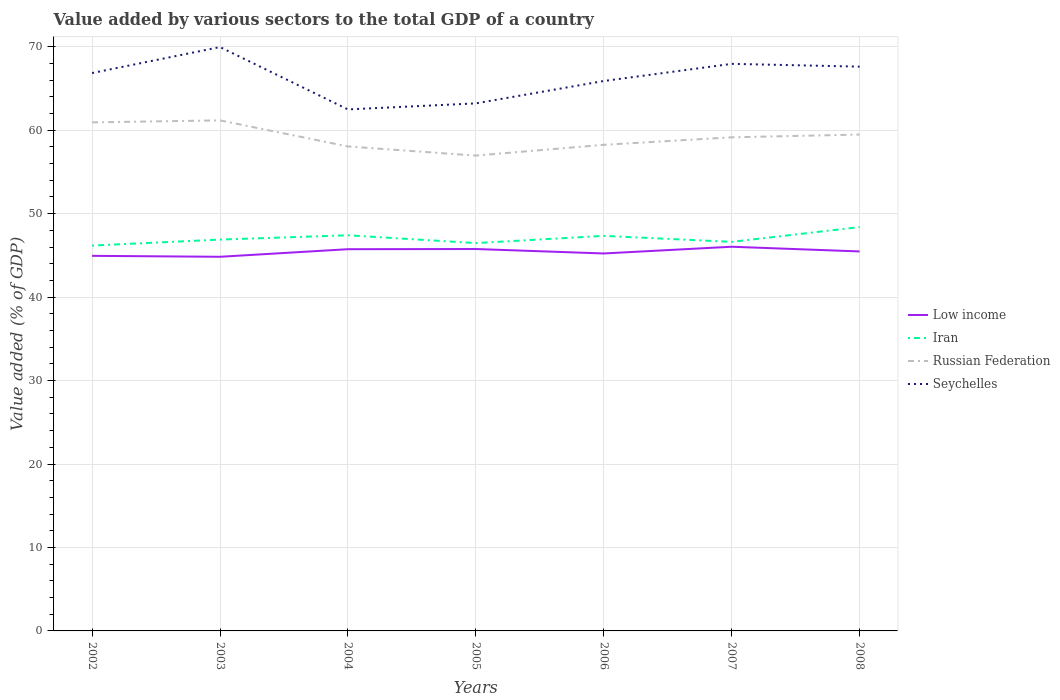How many different coloured lines are there?
Make the answer very short. 4. Is the number of lines equal to the number of legend labels?
Your response must be concise. Yes. Across all years, what is the maximum value added by various sectors to the total GDP in Russian Federation?
Your answer should be compact. 56.96. In which year was the value added by various sectors to the total GDP in Russian Federation maximum?
Offer a terse response. 2005. What is the total value added by various sectors to the total GDP in Iran in the graph?
Offer a terse response. -0.15. What is the difference between the highest and the second highest value added by various sectors to the total GDP in Low income?
Give a very brief answer. 1.2. Does the graph contain any zero values?
Your response must be concise. No. How many legend labels are there?
Keep it short and to the point. 4. What is the title of the graph?
Offer a very short reply. Value added by various sectors to the total GDP of a country. Does "Rwanda" appear as one of the legend labels in the graph?
Make the answer very short. No. What is the label or title of the X-axis?
Ensure brevity in your answer.  Years. What is the label or title of the Y-axis?
Provide a succinct answer. Value added (% of GDP). What is the Value added (% of GDP) in Low income in 2002?
Ensure brevity in your answer.  44.94. What is the Value added (% of GDP) in Iran in 2002?
Give a very brief answer. 46.18. What is the Value added (% of GDP) of Russian Federation in 2002?
Ensure brevity in your answer.  60.94. What is the Value added (% of GDP) in Seychelles in 2002?
Offer a terse response. 66.85. What is the Value added (% of GDP) of Low income in 2003?
Provide a short and direct response. 44.83. What is the Value added (% of GDP) of Iran in 2003?
Your answer should be very brief. 46.89. What is the Value added (% of GDP) in Russian Federation in 2003?
Ensure brevity in your answer.  61.17. What is the Value added (% of GDP) in Seychelles in 2003?
Provide a succinct answer. 69.96. What is the Value added (% of GDP) in Low income in 2004?
Keep it short and to the point. 45.74. What is the Value added (% of GDP) in Iran in 2004?
Offer a terse response. 47.41. What is the Value added (% of GDP) of Russian Federation in 2004?
Ensure brevity in your answer.  58.05. What is the Value added (% of GDP) in Seychelles in 2004?
Provide a succinct answer. 62.49. What is the Value added (% of GDP) of Low income in 2005?
Provide a succinct answer. 45.76. What is the Value added (% of GDP) of Iran in 2005?
Offer a terse response. 46.47. What is the Value added (% of GDP) of Russian Federation in 2005?
Your answer should be very brief. 56.96. What is the Value added (% of GDP) in Seychelles in 2005?
Offer a very short reply. 63.21. What is the Value added (% of GDP) of Low income in 2006?
Your response must be concise. 45.23. What is the Value added (% of GDP) in Iran in 2006?
Provide a succinct answer. 47.34. What is the Value added (% of GDP) of Russian Federation in 2006?
Ensure brevity in your answer.  58.25. What is the Value added (% of GDP) in Seychelles in 2006?
Your answer should be compact. 65.89. What is the Value added (% of GDP) in Low income in 2007?
Ensure brevity in your answer.  46.03. What is the Value added (% of GDP) of Iran in 2007?
Offer a terse response. 46.62. What is the Value added (% of GDP) in Russian Federation in 2007?
Ensure brevity in your answer.  59.15. What is the Value added (% of GDP) of Seychelles in 2007?
Ensure brevity in your answer.  67.95. What is the Value added (% of GDP) in Low income in 2008?
Give a very brief answer. 45.47. What is the Value added (% of GDP) of Iran in 2008?
Your answer should be very brief. 48.39. What is the Value added (% of GDP) of Russian Federation in 2008?
Provide a short and direct response. 59.48. What is the Value added (% of GDP) in Seychelles in 2008?
Make the answer very short. 67.61. Across all years, what is the maximum Value added (% of GDP) of Low income?
Provide a short and direct response. 46.03. Across all years, what is the maximum Value added (% of GDP) in Iran?
Provide a succinct answer. 48.39. Across all years, what is the maximum Value added (% of GDP) of Russian Federation?
Give a very brief answer. 61.17. Across all years, what is the maximum Value added (% of GDP) in Seychelles?
Provide a succinct answer. 69.96. Across all years, what is the minimum Value added (% of GDP) in Low income?
Your answer should be very brief. 44.83. Across all years, what is the minimum Value added (% of GDP) of Iran?
Your answer should be very brief. 46.18. Across all years, what is the minimum Value added (% of GDP) in Russian Federation?
Provide a succinct answer. 56.96. Across all years, what is the minimum Value added (% of GDP) of Seychelles?
Your answer should be compact. 62.49. What is the total Value added (% of GDP) of Low income in the graph?
Offer a terse response. 318. What is the total Value added (% of GDP) in Iran in the graph?
Your answer should be very brief. 329.29. What is the total Value added (% of GDP) of Russian Federation in the graph?
Your answer should be compact. 413.99. What is the total Value added (% of GDP) in Seychelles in the graph?
Provide a short and direct response. 463.97. What is the difference between the Value added (% of GDP) of Low income in 2002 and that in 2003?
Make the answer very short. 0.11. What is the difference between the Value added (% of GDP) in Iran in 2002 and that in 2003?
Provide a succinct answer. -0.72. What is the difference between the Value added (% of GDP) of Russian Federation in 2002 and that in 2003?
Provide a succinct answer. -0.24. What is the difference between the Value added (% of GDP) in Seychelles in 2002 and that in 2003?
Your response must be concise. -3.11. What is the difference between the Value added (% of GDP) in Low income in 2002 and that in 2004?
Keep it short and to the point. -0.8. What is the difference between the Value added (% of GDP) in Iran in 2002 and that in 2004?
Give a very brief answer. -1.23. What is the difference between the Value added (% of GDP) in Russian Federation in 2002 and that in 2004?
Make the answer very short. 2.88. What is the difference between the Value added (% of GDP) in Seychelles in 2002 and that in 2004?
Your response must be concise. 4.36. What is the difference between the Value added (% of GDP) in Low income in 2002 and that in 2005?
Provide a short and direct response. -0.82. What is the difference between the Value added (% of GDP) in Iran in 2002 and that in 2005?
Your answer should be compact. -0.3. What is the difference between the Value added (% of GDP) of Russian Federation in 2002 and that in 2005?
Make the answer very short. 3.98. What is the difference between the Value added (% of GDP) of Seychelles in 2002 and that in 2005?
Your answer should be very brief. 3.64. What is the difference between the Value added (% of GDP) in Low income in 2002 and that in 2006?
Your response must be concise. -0.29. What is the difference between the Value added (% of GDP) of Iran in 2002 and that in 2006?
Provide a succinct answer. -1.16. What is the difference between the Value added (% of GDP) of Russian Federation in 2002 and that in 2006?
Make the answer very short. 2.69. What is the difference between the Value added (% of GDP) in Seychelles in 2002 and that in 2006?
Ensure brevity in your answer.  0.95. What is the difference between the Value added (% of GDP) of Low income in 2002 and that in 2007?
Your answer should be very brief. -1.09. What is the difference between the Value added (% of GDP) in Iran in 2002 and that in 2007?
Give a very brief answer. -0.44. What is the difference between the Value added (% of GDP) in Russian Federation in 2002 and that in 2007?
Offer a terse response. 1.79. What is the difference between the Value added (% of GDP) of Seychelles in 2002 and that in 2007?
Keep it short and to the point. -1.1. What is the difference between the Value added (% of GDP) in Low income in 2002 and that in 2008?
Ensure brevity in your answer.  -0.53. What is the difference between the Value added (% of GDP) of Iran in 2002 and that in 2008?
Ensure brevity in your answer.  -2.22. What is the difference between the Value added (% of GDP) of Russian Federation in 2002 and that in 2008?
Your response must be concise. 1.46. What is the difference between the Value added (% of GDP) in Seychelles in 2002 and that in 2008?
Provide a succinct answer. -0.77. What is the difference between the Value added (% of GDP) of Low income in 2003 and that in 2004?
Make the answer very short. -0.91. What is the difference between the Value added (% of GDP) of Iran in 2003 and that in 2004?
Your answer should be very brief. -0.52. What is the difference between the Value added (% of GDP) in Russian Federation in 2003 and that in 2004?
Keep it short and to the point. 3.12. What is the difference between the Value added (% of GDP) in Seychelles in 2003 and that in 2004?
Your response must be concise. 7.47. What is the difference between the Value added (% of GDP) of Low income in 2003 and that in 2005?
Your response must be concise. -0.93. What is the difference between the Value added (% of GDP) in Iran in 2003 and that in 2005?
Offer a terse response. 0.42. What is the difference between the Value added (% of GDP) in Russian Federation in 2003 and that in 2005?
Your response must be concise. 4.22. What is the difference between the Value added (% of GDP) in Seychelles in 2003 and that in 2005?
Make the answer very short. 6.75. What is the difference between the Value added (% of GDP) of Low income in 2003 and that in 2006?
Ensure brevity in your answer.  -0.4. What is the difference between the Value added (% of GDP) of Iran in 2003 and that in 2006?
Offer a very short reply. -0.45. What is the difference between the Value added (% of GDP) in Russian Federation in 2003 and that in 2006?
Provide a short and direct response. 2.93. What is the difference between the Value added (% of GDP) in Seychelles in 2003 and that in 2006?
Offer a terse response. 4.07. What is the difference between the Value added (% of GDP) in Low income in 2003 and that in 2007?
Give a very brief answer. -1.2. What is the difference between the Value added (% of GDP) in Iran in 2003 and that in 2007?
Give a very brief answer. 0.27. What is the difference between the Value added (% of GDP) of Russian Federation in 2003 and that in 2007?
Provide a succinct answer. 2.03. What is the difference between the Value added (% of GDP) in Seychelles in 2003 and that in 2007?
Your response must be concise. 2.01. What is the difference between the Value added (% of GDP) of Low income in 2003 and that in 2008?
Provide a short and direct response. -0.64. What is the difference between the Value added (% of GDP) in Iran in 2003 and that in 2008?
Keep it short and to the point. -1.5. What is the difference between the Value added (% of GDP) of Russian Federation in 2003 and that in 2008?
Your response must be concise. 1.7. What is the difference between the Value added (% of GDP) in Seychelles in 2003 and that in 2008?
Ensure brevity in your answer.  2.35. What is the difference between the Value added (% of GDP) in Low income in 2004 and that in 2005?
Give a very brief answer. -0.02. What is the difference between the Value added (% of GDP) of Iran in 2004 and that in 2005?
Make the answer very short. 0.94. What is the difference between the Value added (% of GDP) in Russian Federation in 2004 and that in 2005?
Make the answer very short. 1.1. What is the difference between the Value added (% of GDP) in Seychelles in 2004 and that in 2005?
Your answer should be compact. -0.73. What is the difference between the Value added (% of GDP) of Low income in 2004 and that in 2006?
Offer a terse response. 0.51. What is the difference between the Value added (% of GDP) in Iran in 2004 and that in 2006?
Ensure brevity in your answer.  0.07. What is the difference between the Value added (% of GDP) in Russian Federation in 2004 and that in 2006?
Provide a short and direct response. -0.2. What is the difference between the Value added (% of GDP) of Seychelles in 2004 and that in 2006?
Your response must be concise. -3.41. What is the difference between the Value added (% of GDP) of Low income in 2004 and that in 2007?
Ensure brevity in your answer.  -0.3. What is the difference between the Value added (% of GDP) in Iran in 2004 and that in 2007?
Provide a short and direct response. 0.79. What is the difference between the Value added (% of GDP) of Russian Federation in 2004 and that in 2007?
Offer a terse response. -1.1. What is the difference between the Value added (% of GDP) of Seychelles in 2004 and that in 2007?
Your answer should be very brief. -5.46. What is the difference between the Value added (% of GDP) of Low income in 2004 and that in 2008?
Provide a succinct answer. 0.27. What is the difference between the Value added (% of GDP) of Iran in 2004 and that in 2008?
Your answer should be very brief. -0.98. What is the difference between the Value added (% of GDP) in Russian Federation in 2004 and that in 2008?
Keep it short and to the point. -1.43. What is the difference between the Value added (% of GDP) in Seychelles in 2004 and that in 2008?
Provide a succinct answer. -5.13. What is the difference between the Value added (% of GDP) of Low income in 2005 and that in 2006?
Offer a terse response. 0.53. What is the difference between the Value added (% of GDP) in Iran in 2005 and that in 2006?
Offer a very short reply. -0.87. What is the difference between the Value added (% of GDP) of Russian Federation in 2005 and that in 2006?
Give a very brief answer. -1.29. What is the difference between the Value added (% of GDP) of Seychelles in 2005 and that in 2006?
Your response must be concise. -2.68. What is the difference between the Value added (% of GDP) of Low income in 2005 and that in 2007?
Ensure brevity in your answer.  -0.27. What is the difference between the Value added (% of GDP) of Iran in 2005 and that in 2007?
Your answer should be very brief. -0.15. What is the difference between the Value added (% of GDP) of Russian Federation in 2005 and that in 2007?
Your answer should be very brief. -2.19. What is the difference between the Value added (% of GDP) of Seychelles in 2005 and that in 2007?
Provide a short and direct response. -4.74. What is the difference between the Value added (% of GDP) of Low income in 2005 and that in 2008?
Keep it short and to the point. 0.29. What is the difference between the Value added (% of GDP) in Iran in 2005 and that in 2008?
Make the answer very short. -1.92. What is the difference between the Value added (% of GDP) of Russian Federation in 2005 and that in 2008?
Offer a very short reply. -2.52. What is the difference between the Value added (% of GDP) of Seychelles in 2005 and that in 2008?
Make the answer very short. -4.4. What is the difference between the Value added (% of GDP) of Low income in 2006 and that in 2007?
Provide a short and direct response. -0.81. What is the difference between the Value added (% of GDP) of Iran in 2006 and that in 2007?
Offer a terse response. 0.72. What is the difference between the Value added (% of GDP) in Russian Federation in 2006 and that in 2007?
Ensure brevity in your answer.  -0.9. What is the difference between the Value added (% of GDP) in Seychelles in 2006 and that in 2007?
Your response must be concise. -2.05. What is the difference between the Value added (% of GDP) of Low income in 2006 and that in 2008?
Give a very brief answer. -0.24. What is the difference between the Value added (% of GDP) in Iran in 2006 and that in 2008?
Offer a very short reply. -1.05. What is the difference between the Value added (% of GDP) in Russian Federation in 2006 and that in 2008?
Offer a terse response. -1.23. What is the difference between the Value added (% of GDP) of Seychelles in 2006 and that in 2008?
Your response must be concise. -1.72. What is the difference between the Value added (% of GDP) in Low income in 2007 and that in 2008?
Offer a terse response. 0.56. What is the difference between the Value added (% of GDP) of Iran in 2007 and that in 2008?
Keep it short and to the point. -1.77. What is the difference between the Value added (% of GDP) of Russian Federation in 2007 and that in 2008?
Provide a short and direct response. -0.33. What is the difference between the Value added (% of GDP) in Seychelles in 2007 and that in 2008?
Your answer should be compact. 0.33. What is the difference between the Value added (% of GDP) of Low income in 2002 and the Value added (% of GDP) of Iran in 2003?
Make the answer very short. -1.95. What is the difference between the Value added (% of GDP) in Low income in 2002 and the Value added (% of GDP) in Russian Federation in 2003?
Offer a very short reply. -16.23. What is the difference between the Value added (% of GDP) of Low income in 2002 and the Value added (% of GDP) of Seychelles in 2003?
Your answer should be very brief. -25.02. What is the difference between the Value added (% of GDP) in Iran in 2002 and the Value added (% of GDP) in Russian Federation in 2003?
Your response must be concise. -15. What is the difference between the Value added (% of GDP) of Iran in 2002 and the Value added (% of GDP) of Seychelles in 2003?
Keep it short and to the point. -23.79. What is the difference between the Value added (% of GDP) of Russian Federation in 2002 and the Value added (% of GDP) of Seychelles in 2003?
Give a very brief answer. -9.02. What is the difference between the Value added (% of GDP) of Low income in 2002 and the Value added (% of GDP) of Iran in 2004?
Make the answer very short. -2.47. What is the difference between the Value added (% of GDP) of Low income in 2002 and the Value added (% of GDP) of Russian Federation in 2004?
Your answer should be compact. -13.11. What is the difference between the Value added (% of GDP) of Low income in 2002 and the Value added (% of GDP) of Seychelles in 2004?
Provide a succinct answer. -17.54. What is the difference between the Value added (% of GDP) in Iran in 2002 and the Value added (% of GDP) in Russian Federation in 2004?
Ensure brevity in your answer.  -11.88. What is the difference between the Value added (% of GDP) of Iran in 2002 and the Value added (% of GDP) of Seychelles in 2004?
Your answer should be very brief. -16.31. What is the difference between the Value added (% of GDP) in Russian Federation in 2002 and the Value added (% of GDP) in Seychelles in 2004?
Ensure brevity in your answer.  -1.55. What is the difference between the Value added (% of GDP) in Low income in 2002 and the Value added (% of GDP) in Iran in 2005?
Keep it short and to the point. -1.53. What is the difference between the Value added (% of GDP) in Low income in 2002 and the Value added (% of GDP) in Russian Federation in 2005?
Your answer should be very brief. -12.01. What is the difference between the Value added (% of GDP) of Low income in 2002 and the Value added (% of GDP) of Seychelles in 2005?
Offer a terse response. -18.27. What is the difference between the Value added (% of GDP) in Iran in 2002 and the Value added (% of GDP) in Russian Federation in 2005?
Ensure brevity in your answer.  -10.78. What is the difference between the Value added (% of GDP) of Iran in 2002 and the Value added (% of GDP) of Seychelles in 2005?
Offer a very short reply. -17.04. What is the difference between the Value added (% of GDP) in Russian Federation in 2002 and the Value added (% of GDP) in Seychelles in 2005?
Your response must be concise. -2.28. What is the difference between the Value added (% of GDP) of Low income in 2002 and the Value added (% of GDP) of Iran in 2006?
Make the answer very short. -2.39. What is the difference between the Value added (% of GDP) in Low income in 2002 and the Value added (% of GDP) in Russian Federation in 2006?
Your answer should be very brief. -13.3. What is the difference between the Value added (% of GDP) of Low income in 2002 and the Value added (% of GDP) of Seychelles in 2006?
Ensure brevity in your answer.  -20.95. What is the difference between the Value added (% of GDP) of Iran in 2002 and the Value added (% of GDP) of Russian Federation in 2006?
Keep it short and to the point. -12.07. What is the difference between the Value added (% of GDP) in Iran in 2002 and the Value added (% of GDP) in Seychelles in 2006?
Your response must be concise. -19.72. What is the difference between the Value added (% of GDP) of Russian Federation in 2002 and the Value added (% of GDP) of Seychelles in 2006?
Your response must be concise. -4.96. What is the difference between the Value added (% of GDP) in Low income in 2002 and the Value added (% of GDP) in Iran in 2007?
Your response must be concise. -1.68. What is the difference between the Value added (% of GDP) in Low income in 2002 and the Value added (% of GDP) in Russian Federation in 2007?
Ensure brevity in your answer.  -14.2. What is the difference between the Value added (% of GDP) of Low income in 2002 and the Value added (% of GDP) of Seychelles in 2007?
Ensure brevity in your answer.  -23.01. What is the difference between the Value added (% of GDP) of Iran in 2002 and the Value added (% of GDP) of Russian Federation in 2007?
Provide a succinct answer. -12.97. What is the difference between the Value added (% of GDP) of Iran in 2002 and the Value added (% of GDP) of Seychelles in 2007?
Your answer should be compact. -21.77. What is the difference between the Value added (% of GDP) of Russian Federation in 2002 and the Value added (% of GDP) of Seychelles in 2007?
Make the answer very short. -7.01. What is the difference between the Value added (% of GDP) in Low income in 2002 and the Value added (% of GDP) in Iran in 2008?
Give a very brief answer. -3.45. What is the difference between the Value added (% of GDP) of Low income in 2002 and the Value added (% of GDP) of Russian Federation in 2008?
Your answer should be compact. -14.53. What is the difference between the Value added (% of GDP) of Low income in 2002 and the Value added (% of GDP) of Seychelles in 2008?
Give a very brief answer. -22.67. What is the difference between the Value added (% of GDP) of Iran in 2002 and the Value added (% of GDP) of Russian Federation in 2008?
Offer a terse response. -13.3. What is the difference between the Value added (% of GDP) of Iran in 2002 and the Value added (% of GDP) of Seychelles in 2008?
Offer a very short reply. -21.44. What is the difference between the Value added (% of GDP) in Russian Federation in 2002 and the Value added (% of GDP) in Seychelles in 2008?
Your answer should be compact. -6.68. What is the difference between the Value added (% of GDP) in Low income in 2003 and the Value added (% of GDP) in Iran in 2004?
Give a very brief answer. -2.58. What is the difference between the Value added (% of GDP) of Low income in 2003 and the Value added (% of GDP) of Russian Federation in 2004?
Make the answer very short. -13.22. What is the difference between the Value added (% of GDP) of Low income in 2003 and the Value added (% of GDP) of Seychelles in 2004?
Offer a terse response. -17.66. What is the difference between the Value added (% of GDP) of Iran in 2003 and the Value added (% of GDP) of Russian Federation in 2004?
Ensure brevity in your answer.  -11.16. What is the difference between the Value added (% of GDP) in Iran in 2003 and the Value added (% of GDP) in Seychelles in 2004?
Provide a short and direct response. -15.6. What is the difference between the Value added (% of GDP) in Russian Federation in 2003 and the Value added (% of GDP) in Seychelles in 2004?
Provide a short and direct response. -1.31. What is the difference between the Value added (% of GDP) of Low income in 2003 and the Value added (% of GDP) of Iran in 2005?
Provide a succinct answer. -1.64. What is the difference between the Value added (% of GDP) of Low income in 2003 and the Value added (% of GDP) of Russian Federation in 2005?
Your answer should be very brief. -12.13. What is the difference between the Value added (% of GDP) of Low income in 2003 and the Value added (% of GDP) of Seychelles in 2005?
Ensure brevity in your answer.  -18.38. What is the difference between the Value added (% of GDP) in Iran in 2003 and the Value added (% of GDP) in Russian Federation in 2005?
Your answer should be very brief. -10.06. What is the difference between the Value added (% of GDP) of Iran in 2003 and the Value added (% of GDP) of Seychelles in 2005?
Give a very brief answer. -16.32. What is the difference between the Value added (% of GDP) of Russian Federation in 2003 and the Value added (% of GDP) of Seychelles in 2005?
Offer a terse response. -2.04. What is the difference between the Value added (% of GDP) of Low income in 2003 and the Value added (% of GDP) of Iran in 2006?
Offer a terse response. -2.51. What is the difference between the Value added (% of GDP) in Low income in 2003 and the Value added (% of GDP) in Russian Federation in 2006?
Offer a very short reply. -13.42. What is the difference between the Value added (% of GDP) in Low income in 2003 and the Value added (% of GDP) in Seychelles in 2006?
Offer a very short reply. -21.06. What is the difference between the Value added (% of GDP) in Iran in 2003 and the Value added (% of GDP) in Russian Federation in 2006?
Provide a short and direct response. -11.36. What is the difference between the Value added (% of GDP) in Iran in 2003 and the Value added (% of GDP) in Seychelles in 2006?
Your answer should be very brief. -19. What is the difference between the Value added (% of GDP) in Russian Federation in 2003 and the Value added (% of GDP) in Seychelles in 2006?
Provide a succinct answer. -4.72. What is the difference between the Value added (% of GDP) in Low income in 2003 and the Value added (% of GDP) in Iran in 2007?
Keep it short and to the point. -1.79. What is the difference between the Value added (% of GDP) of Low income in 2003 and the Value added (% of GDP) of Russian Federation in 2007?
Keep it short and to the point. -14.32. What is the difference between the Value added (% of GDP) of Low income in 2003 and the Value added (% of GDP) of Seychelles in 2007?
Offer a very short reply. -23.12. What is the difference between the Value added (% of GDP) of Iran in 2003 and the Value added (% of GDP) of Russian Federation in 2007?
Make the answer very short. -12.26. What is the difference between the Value added (% of GDP) of Iran in 2003 and the Value added (% of GDP) of Seychelles in 2007?
Keep it short and to the point. -21.06. What is the difference between the Value added (% of GDP) of Russian Federation in 2003 and the Value added (% of GDP) of Seychelles in 2007?
Your answer should be compact. -6.77. What is the difference between the Value added (% of GDP) of Low income in 2003 and the Value added (% of GDP) of Iran in 2008?
Keep it short and to the point. -3.56. What is the difference between the Value added (% of GDP) in Low income in 2003 and the Value added (% of GDP) in Russian Federation in 2008?
Ensure brevity in your answer.  -14.65. What is the difference between the Value added (% of GDP) in Low income in 2003 and the Value added (% of GDP) in Seychelles in 2008?
Your answer should be compact. -22.78. What is the difference between the Value added (% of GDP) of Iran in 2003 and the Value added (% of GDP) of Russian Federation in 2008?
Offer a terse response. -12.59. What is the difference between the Value added (% of GDP) in Iran in 2003 and the Value added (% of GDP) in Seychelles in 2008?
Make the answer very short. -20.72. What is the difference between the Value added (% of GDP) of Russian Federation in 2003 and the Value added (% of GDP) of Seychelles in 2008?
Offer a very short reply. -6.44. What is the difference between the Value added (% of GDP) of Low income in 2004 and the Value added (% of GDP) of Iran in 2005?
Provide a short and direct response. -0.73. What is the difference between the Value added (% of GDP) in Low income in 2004 and the Value added (% of GDP) in Russian Federation in 2005?
Ensure brevity in your answer.  -11.22. What is the difference between the Value added (% of GDP) in Low income in 2004 and the Value added (% of GDP) in Seychelles in 2005?
Your response must be concise. -17.47. What is the difference between the Value added (% of GDP) of Iran in 2004 and the Value added (% of GDP) of Russian Federation in 2005?
Offer a very short reply. -9.55. What is the difference between the Value added (% of GDP) of Iran in 2004 and the Value added (% of GDP) of Seychelles in 2005?
Your response must be concise. -15.8. What is the difference between the Value added (% of GDP) in Russian Federation in 2004 and the Value added (% of GDP) in Seychelles in 2005?
Offer a very short reply. -5.16. What is the difference between the Value added (% of GDP) in Low income in 2004 and the Value added (% of GDP) in Iran in 2006?
Provide a succinct answer. -1.6. What is the difference between the Value added (% of GDP) of Low income in 2004 and the Value added (% of GDP) of Russian Federation in 2006?
Offer a terse response. -12.51. What is the difference between the Value added (% of GDP) in Low income in 2004 and the Value added (% of GDP) in Seychelles in 2006?
Provide a short and direct response. -20.16. What is the difference between the Value added (% of GDP) of Iran in 2004 and the Value added (% of GDP) of Russian Federation in 2006?
Ensure brevity in your answer.  -10.84. What is the difference between the Value added (% of GDP) in Iran in 2004 and the Value added (% of GDP) in Seychelles in 2006?
Ensure brevity in your answer.  -18.49. What is the difference between the Value added (% of GDP) of Russian Federation in 2004 and the Value added (% of GDP) of Seychelles in 2006?
Ensure brevity in your answer.  -7.84. What is the difference between the Value added (% of GDP) of Low income in 2004 and the Value added (% of GDP) of Iran in 2007?
Offer a terse response. -0.88. What is the difference between the Value added (% of GDP) in Low income in 2004 and the Value added (% of GDP) in Russian Federation in 2007?
Ensure brevity in your answer.  -13.41. What is the difference between the Value added (% of GDP) of Low income in 2004 and the Value added (% of GDP) of Seychelles in 2007?
Your answer should be compact. -22.21. What is the difference between the Value added (% of GDP) of Iran in 2004 and the Value added (% of GDP) of Russian Federation in 2007?
Your answer should be compact. -11.74. What is the difference between the Value added (% of GDP) in Iran in 2004 and the Value added (% of GDP) in Seychelles in 2007?
Provide a short and direct response. -20.54. What is the difference between the Value added (% of GDP) in Russian Federation in 2004 and the Value added (% of GDP) in Seychelles in 2007?
Your answer should be very brief. -9.9. What is the difference between the Value added (% of GDP) in Low income in 2004 and the Value added (% of GDP) in Iran in 2008?
Offer a terse response. -2.65. What is the difference between the Value added (% of GDP) of Low income in 2004 and the Value added (% of GDP) of Russian Federation in 2008?
Your answer should be compact. -13.74. What is the difference between the Value added (% of GDP) in Low income in 2004 and the Value added (% of GDP) in Seychelles in 2008?
Keep it short and to the point. -21.88. What is the difference between the Value added (% of GDP) of Iran in 2004 and the Value added (% of GDP) of Russian Federation in 2008?
Your answer should be very brief. -12.07. What is the difference between the Value added (% of GDP) of Iran in 2004 and the Value added (% of GDP) of Seychelles in 2008?
Your response must be concise. -20.21. What is the difference between the Value added (% of GDP) in Russian Federation in 2004 and the Value added (% of GDP) in Seychelles in 2008?
Give a very brief answer. -9.56. What is the difference between the Value added (% of GDP) in Low income in 2005 and the Value added (% of GDP) in Iran in 2006?
Your answer should be compact. -1.58. What is the difference between the Value added (% of GDP) of Low income in 2005 and the Value added (% of GDP) of Russian Federation in 2006?
Ensure brevity in your answer.  -12.49. What is the difference between the Value added (% of GDP) in Low income in 2005 and the Value added (% of GDP) in Seychelles in 2006?
Offer a terse response. -20.13. What is the difference between the Value added (% of GDP) in Iran in 2005 and the Value added (% of GDP) in Russian Federation in 2006?
Make the answer very short. -11.78. What is the difference between the Value added (% of GDP) of Iran in 2005 and the Value added (% of GDP) of Seychelles in 2006?
Offer a very short reply. -19.42. What is the difference between the Value added (% of GDP) in Russian Federation in 2005 and the Value added (% of GDP) in Seychelles in 2006?
Offer a terse response. -8.94. What is the difference between the Value added (% of GDP) in Low income in 2005 and the Value added (% of GDP) in Iran in 2007?
Your answer should be compact. -0.86. What is the difference between the Value added (% of GDP) of Low income in 2005 and the Value added (% of GDP) of Russian Federation in 2007?
Give a very brief answer. -13.39. What is the difference between the Value added (% of GDP) in Low income in 2005 and the Value added (% of GDP) in Seychelles in 2007?
Offer a terse response. -22.19. What is the difference between the Value added (% of GDP) of Iran in 2005 and the Value added (% of GDP) of Russian Federation in 2007?
Your response must be concise. -12.68. What is the difference between the Value added (% of GDP) in Iran in 2005 and the Value added (% of GDP) in Seychelles in 2007?
Your answer should be very brief. -21.48. What is the difference between the Value added (% of GDP) in Russian Federation in 2005 and the Value added (% of GDP) in Seychelles in 2007?
Your answer should be very brief. -10.99. What is the difference between the Value added (% of GDP) in Low income in 2005 and the Value added (% of GDP) in Iran in 2008?
Offer a very short reply. -2.63. What is the difference between the Value added (% of GDP) in Low income in 2005 and the Value added (% of GDP) in Russian Federation in 2008?
Keep it short and to the point. -13.72. What is the difference between the Value added (% of GDP) of Low income in 2005 and the Value added (% of GDP) of Seychelles in 2008?
Make the answer very short. -21.85. What is the difference between the Value added (% of GDP) in Iran in 2005 and the Value added (% of GDP) in Russian Federation in 2008?
Provide a succinct answer. -13.01. What is the difference between the Value added (% of GDP) of Iran in 2005 and the Value added (% of GDP) of Seychelles in 2008?
Ensure brevity in your answer.  -21.14. What is the difference between the Value added (% of GDP) in Russian Federation in 2005 and the Value added (% of GDP) in Seychelles in 2008?
Make the answer very short. -10.66. What is the difference between the Value added (% of GDP) in Low income in 2006 and the Value added (% of GDP) in Iran in 2007?
Provide a succinct answer. -1.39. What is the difference between the Value added (% of GDP) in Low income in 2006 and the Value added (% of GDP) in Russian Federation in 2007?
Provide a short and direct response. -13.92. What is the difference between the Value added (% of GDP) in Low income in 2006 and the Value added (% of GDP) in Seychelles in 2007?
Make the answer very short. -22.72. What is the difference between the Value added (% of GDP) of Iran in 2006 and the Value added (% of GDP) of Russian Federation in 2007?
Provide a short and direct response. -11.81. What is the difference between the Value added (% of GDP) in Iran in 2006 and the Value added (% of GDP) in Seychelles in 2007?
Ensure brevity in your answer.  -20.61. What is the difference between the Value added (% of GDP) of Russian Federation in 2006 and the Value added (% of GDP) of Seychelles in 2007?
Provide a succinct answer. -9.7. What is the difference between the Value added (% of GDP) of Low income in 2006 and the Value added (% of GDP) of Iran in 2008?
Ensure brevity in your answer.  -3.16. What is the difference between the Value added (% of GDP) of Low income in 2006 and the Value added (% of GDP) of Russian Federation in 2008?
Keep it short and to the point. -14.25. What is the difference between the Value added (% of GDP) of Low income in 2006 and the Value added (% of GDP) of Seychelles in 2008?
Provide a succinct answer. -22.39. What is the difference between the Value added (% of GDP) in Iran in 2006 and the Value added (% of GDP) in Russian Federation in 2008?
Offer a terse response. -12.14. What is the difference between the Value added (% of GDP) in Iran in 2006 and the Value added (% of GDP) in Seychelles in 2008?
Provide a short and direct response. -20.28. What is the difference between the Value added (% of GDP) in Russian Federation in 2006 and the Value added (% of GDP) in Seychelles in 2008?
Your answer should be compact. -9.37. What is the difference between the Value added (% of GDP) of Low income in 2007 and the Value added (% of GDP) of Iran in 2008?
Provide a succinct answer. -2.36. What is the difference between the Value added (% of GDP) in Low income in 2007 and the Value added (% of GDP) in Russian Federation in 2008?
Your answer should be compact. -13.44. What is the difference between the Value added (% of GDP) of Low income in 2007 and the Value added (% of GDP) of Seychelles in 2008?
Your answer should be compact. -21.58. What is the difference between the Value added (% of GDP) in Iran in 2007 and the Value added (% of GDP) in Russian Federation in 2008?
Your answer should be compact. -12.86. What is the difference between the Value added (% of GDP) of Iran in 2007 and the Value added (% of GDP) of Seychelles in 2008?
Your response must be concise. -21. What is the difference between the Value added (% of GDP) of Russian Federation in 2007 and the Value added (% of GDP) of Seychelles in 2008?
Provide a succinct answer. -8.47. What is the average Value added (% of GDP) in Low income per year?
Offer a terse response. 45.43. What is the average Value added (% of GDP) of Iran per year?
Offer a very short reply. 47.04. What is the average Value added (% of GDP) of Russian Federation per year?
Your answer should be compact. 59.14. What is the average Value added (% of GDP) of Seychelles per year?
Your answer should be very brief. 66.28. In the year 2002, what is the difference between the Value added (% of GDP) of Low income and Value added (% of GDP) of Iran?
Your answer should be very brief. -1.23. In the year 2002, what is the difference between the Value added (% of GDP) of Low income and Value added (% of GDP) of Russian Federation?
Your answer should be compact. -15.99. In the year 2002, what is the difference between the Value added (% of GDP) in Low income and Value added (% of GDP) in Seychelles?
Your answer should be very brief. -21.91. In the year 2002, what is the difference between the Value added (% of GDP) in Iran and Value added (% of GDP) in Russian Federation?
Ensure brevity in your answer.  -14.76. In the year 2002, what is the difference between the Value added (% of GDP) in Iran and Value added (% of GDP) in Seychelles?
Provide a short and direct response. -20.67. In the year 2002, what is the difference between the Value added (% of GDP) of Russian Federation and Value added (% of GDP) of Seychelles?
Make the answer very short. -5.91. In the year 2003, what is the difference between the Value added (% of GDP) of Low income and Value added (% of GDP) of Iran?
Give a very brief answer. -2.06. In the year 2003, what is the difference between the Value added (% of GDP) in Low income and Value added (% of GDP) in Russian Federation?
Your answer should be compact. -16.34. In the year 2003, what is the difference between the Value added (% of GDP) in Low income and Value added (% of GDP) in Seychelles?
Your answer should be compact. -25.13. In the year 2003, what is the difference between the Value added (% of GDP) in Iran and Value added (% of GDP) in Russian Federation?
Provide a short and direct response. -14.28. In the year 2003, what is the difference between the Value added (% of GDP) in Iran and Value added (% of GDP) in Seychelles?
Your answer should be very brief. -23.07. In the year 2003, what is the difference between the Value added (% of GDP) in Russian Federation and Value added (% of GDP) in Seychelles?
Ensure brevity in your answer.  -8.79. In the year 2004, what is the difference between the Value added (% of GDP) in Low income and Value added (% of GDP) in Iran?
Your answer should be very brief. -1.67. In the year 2004, what is the difference between the Value added (% of GDP) in Low income and Value added (% of GDP) in Russian Federation?
Make the answer very short. -12.31. In the year 2004, what is the difference between the Value added (% of GDP) in Low income and Value added (% of GDP) in Seychelles?
Give a very brief answer. -16.75. In the year 2004, what is the difference between the Value added (% of GDP) in Iran and Value added (% of GDP) in Russian Federation?
Your answer should be very brief. -10.64. In the year 2004, what is the difference between the Value added (% of GDP) in Iran and Value added (% of GDP) in Seychelles?
Offer a terse response. -15.08. In the year 2004, what is the difference between the Value added (% of GDP) in Russian Federation and Value added (% of GDP) in Seychelles?
Give a very brief answer. -4.44. In the year 2005, what is the difference between the Value added (% of GDP) of Low income and Value added (% of GDP) of Iran?
Keep it short and to the point. -0.71. In the year 2005, what is the difference between the Value added (% of GDP) of Low income and Value added (% of GDP) of Russian Federation?
Your answer should be very brief. -11.2. In the year 2005, what is the difference between the Value added (% of GDP) of Low income and Value added (% of GDP) of Seychelles?
Keep it short and to the point. -17.45. In the year 2005, what is the difference between the Value added (% of GDP) of Iran and Value added (% of GDP) of Russian Federation?
Your answer should be very brief. -10.48. In the year 2005, what is the difference between the Value added (% of GDP) of Iran and Value added (% of GDP) of Seychelles?
Your answer should be compact. -16.74. In the year 2005, what is the difference between the Value added (% of GDP) of Russian Federation and Value added (% of GDP) of Seychelles?
Keep it short and to the point. -6.26. In the year 2006, what is the difference between the Value added (% of GDP) of Low income and Value added (% of GDP) of Iran?
Make the answer very short. -2.11. In the year 2006, what is the difference between the Value added (% of GDP) in Low income and Value added (% of GDP) in Russian Federation?
Ensure brevity in your answer.  -13.02. In the year 2006, what is the difference between the Value added (% of GDP) of Low income and Value added (% of GDP) of Seychelles?
Provide a succinct answer. -20.67. In the year 2006, what is the difference between the Value added (% of GDP) of Iran and Value added (% of GDP) of Russian Federation?
Your answer should be very brief. -10.91. In the year 2006, what is the difference between the Value added (% of GDP) in Iran and Value added (% of GDP) in Seychelles?
Give a very brief answer. -18.56. In the year 2006, what is the difference between the Value added (% of GDP) of Russian Federation and Value added (% of GDP) of Seychelles?
Make the answer very short. -7.65. In the year 2007, what is the difference between the Value added (% of GDP) in Low income and Value added (% of GDP) in Iran?
Ensure brevity in your answer.  -0.58. In the year 2007, what is the difference between the Value added (% of GDP) in Low income and Value added (% of GDP) in Russian Federation?
Give a very brief answer. -13.11. In the year 2007, what is the difference between the Value added (% of GDP) of Low income and Value added (% of GDP) of Seychelles?
Your answer should be very brief. -21.91. In the year 2007, what is the difference between the Value added (% of GDP) of Iran and Value added (% of GDP) of Russian Federation?
Offer a terse response. -12.53. In the year 2007, what is the difference between the Value added (% of GDP) in Iran and Value added (% of GDP) in Seychelles?
Keep it short and to the point. -21.33. In the year 2007, what is the difference between the Value added (% of GDP) of Russian Federation and Value added (% of GDP) of Seychelles?
Your answer should be very brief. -8.8. In the year 2008, what is the difference between the Value added (% of GDP) in Low income and Value added (% of GDP) in Iran?
Provide a short and direct response. -2.92. In the year 2008, what is the difference between the Value added (% of GDP) in Low income and Value added (% of GDP) in Russian Federation?
Offer a very short reply. -14.01. In the year 2008, what is the difference between the Value added (% of GDP) of Low income and Value added (% of GDP) of Seychelles?
Provide a short and direct response. -22.14. In the year 2008, what is the difference between the Value added (% of GDP) of Iran and Value added (% of GDP) of Russian Federation?
Provide a short and direct response. -11.09. In the year 2008, what is the difference between the Value added (% of GDP) in Iran and Value added (% of GDP) in Seychelles?
Offer a very short reply. -19.22. In the year 2008, what is the difference between the Value added (% of GDP) of Russian Federation and Value added (% of GDP) of Seychelles?
Your answer should be compact. -8.14. What is the ratio of the Value added (% of GDP) of Low income in 2002 to that in 2003?
Your answer should be compact. 1. What is the ratio of the Value added (% of GDP) of Iran in 2002 to that in 2003?
Your answer should be very brief. 0.98. What is the ratio of the Value added (% of GDP) of Russian Federation in 2002 to that in 2003?
Your answer should be compact. 1. What is the ratio of the Value added (% of GDP) in Seychelles in 2002 to that in 2003?
Your answer should be very brief. 0.96. What is the ratio of the Value added (% of GDP) of Low income in 2002 to that in 2004?
Make the answer very short. 0.98. What is the ratio of the Value added (% of GDP) in Iran in 2002 to that in 2004?
Offer a terse response. 0.97. What is the ratio of the Value added (% of GDP) of Russian Federation in 2002 to that in 2004?
Offer a terse response. 1.05. What is the ratio of the Value added (% of GDP) in Seychelles in 2002 to that in 2004?
Keep it short and to the point. 1.07. What is the ratio of the Value added (% of GDP) in Low income in 2002 to that in 2005?
Offer a terse response. 0.98. What is the ratio of the Value added (% of GDP) in Russian Federation in 2002 to that in 2005?
Keep it short and to the point. 1.07. What is the ratio of the Value added (% of GDP) in Seychelles in 2002 to that in 2005?
Provide a succinct answer. 1.06. What is the ratio of the Value added (% of GDP) of Low income in 2002 to that in 2006?
Your answer should be very brief. 0.99. What is the ratio of the Value added (% of GDP) of Iran in 2002 to that in 2006?
Offer a terse response. 0.98. What is the ratio of the Value added (% of GDP) in Russian Federation in 2002 to that in 2006?
Keep it short and to the point. 1.05. What is the ratio of the Value added (% of GDP) in Seychelles in 2002 to that in 2006?
Keep it short and to the point. 1.01. What is the ratio of the Value added (% of GDP) in Low income in 2002 to that in 2007?
Give a very brief answer. 0.98. What is the ratio of the Value added (% of GDP) of Russian Federation in 2002 to that in 2007?
Offer a terse response. 1.03. What is the ratio of the Value added (% of GDP) in Seychelles in 2002 to that in 2007?
Give a very brief answer. 0.98. What is the ratio of the Value added (% of GDP) in Low income in 2002 to that in 2008?
Your response must be concise. 0.99. What is the ratio of the Value added (% of GDP) of Iran in 2002 to that in 2008?
Offer a very short reply. 0.95. What is the ratio of the Value added (% of GDP) in Russian Federation in 2002 to that in 2008?
Offer a very short reply. 1.02. What is the ratio of the Value added (% of GDP) in Seychelles in 2002 to that in 2008?
Your response must be concise. 0.99. What is the ratio of the Value added (% of GDP) in Low income in 2003 to that in 2004?
Provide a succinct answer. 0.98. What is the ratio of the Value added (% of GDP) of Iran in 2003 to that in 2004?
Your response must be concise. 0.99. What is the ratio of the Value added (% of GDP) of Russian Federation in 2003 to that in 2004?
Provide a short and direct response. 1.05. What is the ratio of the Value added (% of GDP) of Seychelles in 2003 to that in 2004?
Your answer should be very brief. 1.12. What is the ratio of the Value added (% of GDP) in Low income in 2003 to that in 2005?
Provide a succinct answer. 0.98. What is the ratio of the Value added (% of GDP) in Russian Federation in 2003 to that in 2005?
Your answer should be compact. 1.07. What is the ratio of the Value added (% of GDP) in Seychelles in 2003 to that in 2005?
Offer a very short reply. 1.11. What is the ratio of the Value added (% of GDP) of Low income in 2003 to that in 2006?
Your answer should be compact. 0.99. What is the ratio of the Value added (% of GDP) in Iran in 2003 to that in 2006?
Provide a succinct answer. 0.99. What is the ratio of the Value added (% of GDP) in Russian Federation in 2003 to that in 2006?
Keep it short and to the point. 1.05. What is the ratio of the Value added (% of GDP) of Seychelles in 2003 to that in 2006?
Provide a succinct answer. 1.06. What is the ratio of the Value added (% of GDP) in Low income in 2003 to that in 2007?
Your answer should be very brief. 0.97. What is the ratio of the Value added (% of GDP) of Iran in 2003 to that in 2007?
Keep it short and to the point. 1.01. What is the ratio of the Value added (% of GDP) of Russian Federation in 2003 to that in 2007?
Provide a succinct answer. 1.03. What is the ratio of the Value added (% of GDP) of Seychelles in 2003 to that in 2007?
Keep it short and to the point. 1.03. What is the ratio of the Value added (% of GDP) in Low income in 2003 to that in 2008?
Make the answer very short. 0.99. What is the ratio of the Value added (% of GDP) in Russian Federation in 2003 to that in 2008?
Offer a very short reply. 1.03. What is the ratio of the Value added (% of GDP) of Seychelles in 2003 to that in 2008?
Provide a short and direct response. 1.03. What is the ratio of the Value added (% of GDP) in Low income in 2004 to that in 2005?
Offer a very short reply. 1. What is the ratio of the Value added (% of GDP) in Iran in 2004 to that in 2005?
Your answer should be very brief. 1.02. What is the ratio of the Value added (% of GDP) in Russian Federation in 2004 to that in 2005?
Give a very brief answer. 1.02. What is the ratio of the Value added (% of GDP) of Low income in 2004 to that in 2006?
Provide a succinct answer. 1.01. What is the ratio of the Value added (% of GDP) in Iran in 2004 to that in 2006?
Your answer should be compact. 1. What is the ratio of the Value added (% of GDP) of Russian Federation in 2004 to that in 2006?
Offer a terse response. 1. What is the ratio of the Value added (% of GDP) in Seychelles in 2004 to that in 2006?
Provide a short and direct response. 0.95. What is the ratio of the Value added (% of GDP) in Low income in 2004 to that in 2007?
Your answer should be compact. 0.99. What is the ratio of the Value added (% of GDP) of Iran in 2004 to that in 2007?
Your answer should be compact. 1.02. What is the ratio of the Value added (% of GDP) of Russian Federation in 2004 to that in 2007?
Give a very brief answer. 0.98. What is the ratio of the Value added (% of GDP) of Seychelles in 2004 to that in 2007?
Provide a succinct answer. 0.92. What is the ratio of the Value added (% of GDP) in Low income in 2004 to that in 2008?
Make the answer very short. 1.01. What is the ratio of the Value added (% of GDP) of Iran in 2004 to that in 2008?
Offer a very short reply. 0.98. What is the ratio of the Value added (% of GDP) in Seychelles in 2004 to that in 2008?
Ensure brevity in your answer.  0.92. What is the ratio of the Value added (% of GDP) of Low income in 2005 to that in 2006?
Offer a very short reply. 1.01. What is the ratio of the Value added (% of GDP) of Iran in 2005 to that in 2006?
Provide a short and direct response. 0.98. What is the ratio of the Value added (% of GDP) of Russian Federation in 2005 to that in 2006?
Offer a very short reply. 0.98. What is the ratio of the Value added (% of GDP) in Seychelles in 2005 to that in 2006?
Make the answer very short. 0.96. What is the ratio of the Value added (% of GDP) of Russian Federation in 2005 to that in 2007?
Your answer should be compact. 0.96. What is the ratio of the Value added (% of GDP) in Seychelles in 2005 to that in 2007?
Make the answer very short. 0.93. What is the ratio of the Value added (% of GDP) in Low income in 2005 to that in 2008?
Give a very brief answer. 1.01. What is the ratio of the Value added (% of GDP) in Iran in 2005 to that in 2008?
Keep it short and to the point. 0.96. What is the ratio of the Value added (% of GDP) of Russian Federation in 2005 to that in 2008?
Your answer should be compact. 0.96. What is the ratio of the Value added (% of GDP) in Seychelles in 2005 to that in 2008?
Your answer should be very brief. 0.93. What is the ratio of the Value added (% of GDP) of Low income in 2006 to that in 2007?
Provide a succinct answer. 0.98. What is the ratio of the Value added (% of GDP) in Iran in 2006 to that in 2007?
Your response must be concise. 1.02. What is the ratio of the Value added (% of GDP) in Seychelles in 2006 to that in 2007?
Provide a short and direct response. 0.97. What is the ratio of the Value added (% of GDP) in Low income in 2006 to that in 2008?
Give a very brief answer. 0.99. What is the ratio of the Value added (% of GDP) in Iran in 2006 to that in 2008?
Your response must be concise. 0.98. What is the ratio of the Value added (% of GDP) in Russian Federation in 2006 to that in 2008?
Offer a terse response. 0.98. What is the ratio of the Value added (% of GDP) of Seychelles in 2006 to that in 2008?
Your answer should be compact. 0.97. What is the ratio of the Value added (% of GDP) in Low income in 2007 to that in 2008?
Keep it short and to the point. 1.01. What is the ratio of the Value added (% of GDP) in Iran in 2007 to that in 2008?
Offer a very short reply. 0.96. What is the difference between the highest and the second highest Value added (% of GDP) of Low income?
Your answer should be very brief. 0.27. What is the difference between the highest and the second highest Value added (% of GDP) of Iran?
Ensure brevity in your answer.  0.98. What is the difference between the highest and the second highest Value added (% of GDP) of Russian Federation?
Keep it short and to the point. 0.24. What is the difference between the highest and the second highest Value added (% of GDP) of Seychelles?
Provide a short and direct response. 2.01. What is the difference between the highest and the lowest Value added (% of GDP) of Low income?
Keep it short and to the point. 1.2. What is the difference between the highest and the lowest Value added (% of GDP) of Iran?
Keep it short and to the point. 2.22. What is the difference between the highest and the lowest Value added (% of GDP) in Russian Federation?
Make the answer very short. 4.22. What is the difference between the highest and the lowest Value added (% of GDP) of Seychelles?
Keep it short and to the point. 7.47. 